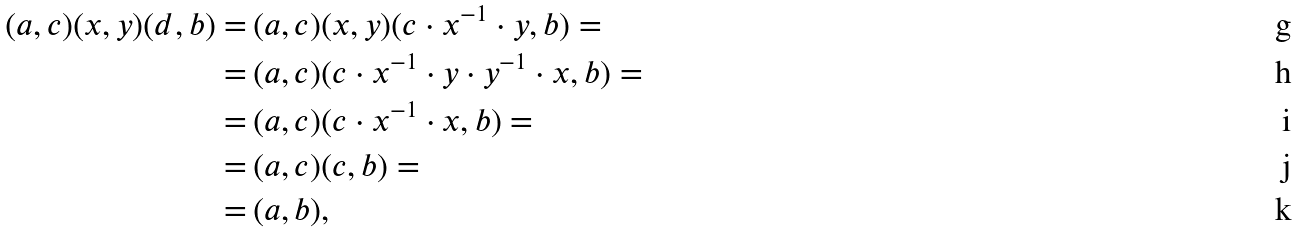<formula> <loc_0><loc_0><loc_500><loc_500>( a , c ) ( x , y ) ( d , b ) = & \, ( a , c ) ( x , y ) ( c \cdot x ^ { - 1 } \cdot y , b ) = \\ = & \, ( a , c ) ( c \cdot x ^ { - 1 } \cdot y \cdot y ^ { - 1 } \cdot x , b ) = \\ = & \, ( a , c ) ( c \cdot x ^ { - 1 } \cdot x , b ) = \\ = & \, ( a , c ) ( c , b ) = \\ = & \, ( a , b ) ,</formula> 